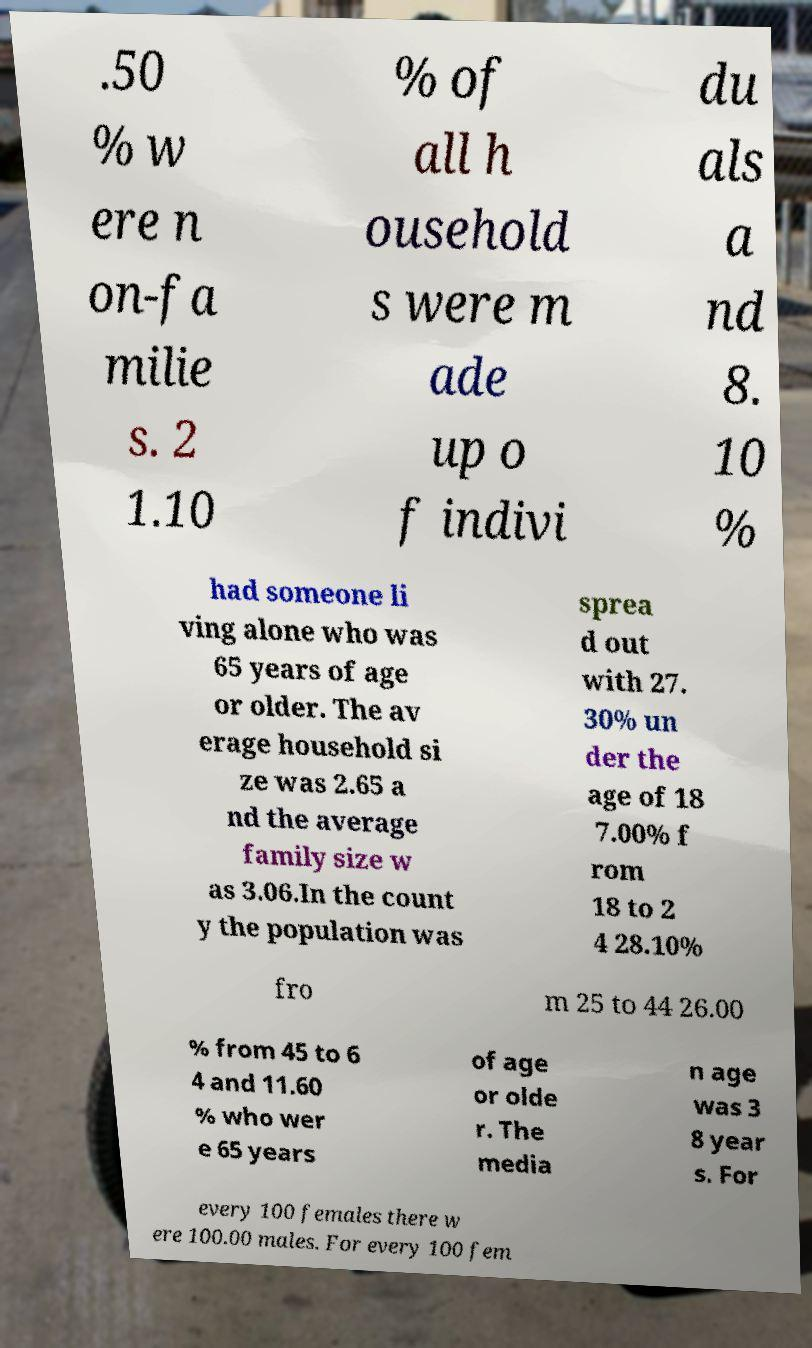Could you assist in decoding the text presented in this image and type it out clearly? .50 % w ere n on-fa milie s. 2 1.10 % of all h ousehold s were m ade up o f indivi du als a nd 8. 10 % had someone li ving alone who was 65 years of age or older. The av erage household si ze was 2.65 a nd the average family size w as 3.06.In the count y the population was sprea d out with 27. 30% un der the age of 18 7.00% f rom 18 to 2 4 28.10% fro m 25 to 44 26.00 % from 45 to 6 4 and 11.60 % who wer e 65 years of age or olde r. The media n age was 3 8 year s. For every 100 females there w ere 100.00 males. For every 100 fem 